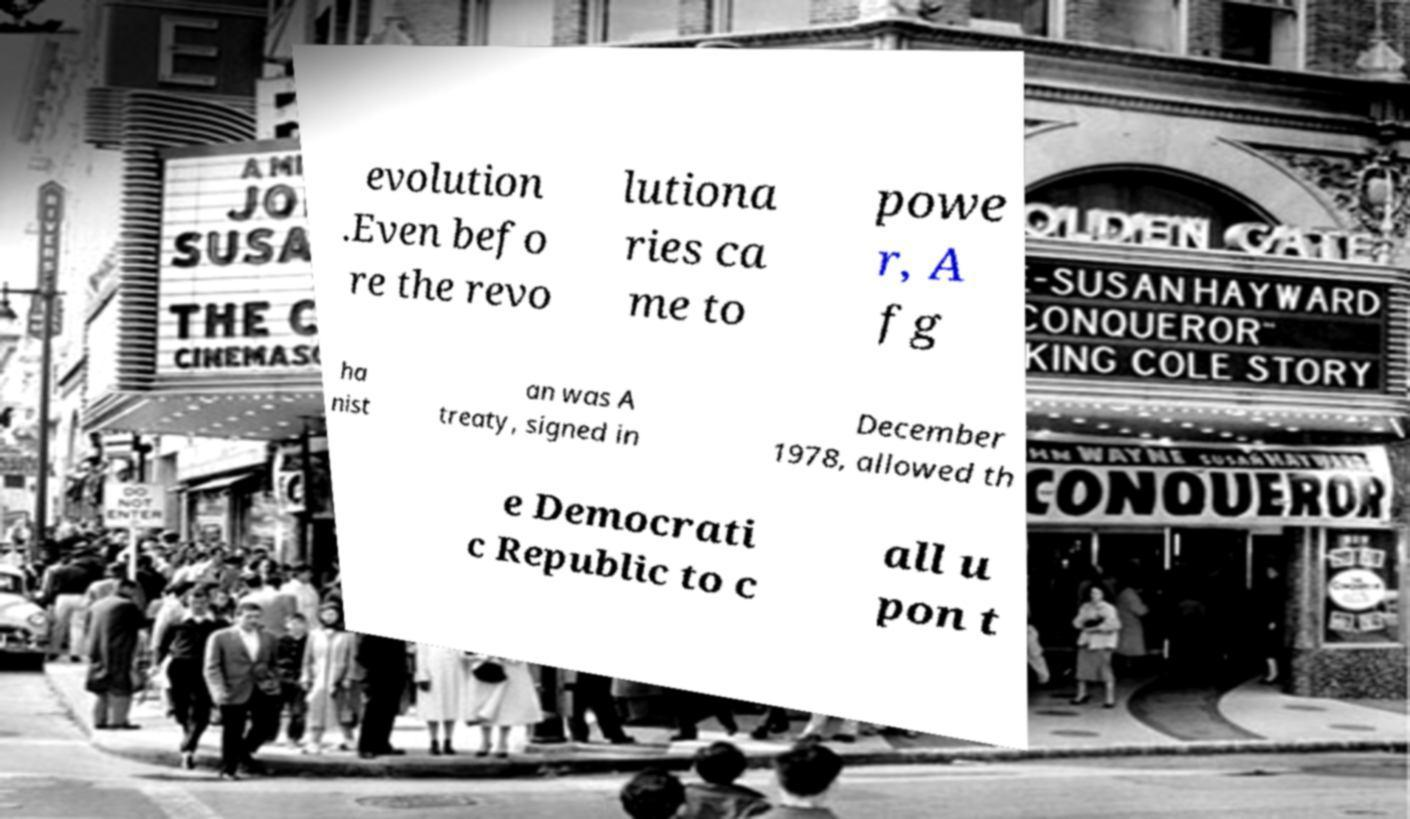Can you read and provide the text displayed in the image?This photo seems to have some interesting text. Can you extract and type it out for me? evolution .Even befo re the revo lutiona ries ca me to powe r, A fg ha nist an was A treaty, signed in December 1978, allowed th e Democrati c Republic to c all u pon t 